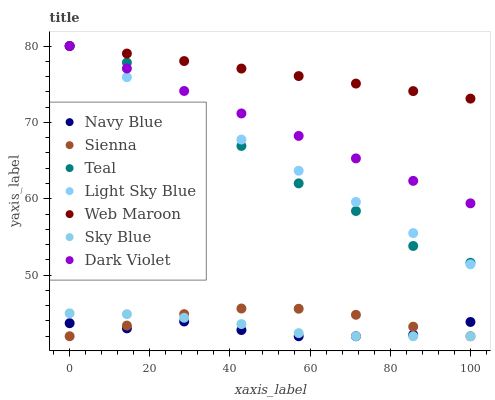Does Navy Blue have the minimum area under the curve?
Answer yes or no. Yes. Does Web Maroon have the maximum area under the curve?
Answer yes or no. Yes. Does Dark Violet have the minimum area under the curve?
Answer yes or no. No. Does Dark Violet have the maximum area under the curve?
Answer yes or no. No. Is Light Sky Blue the smoothest?
Answer yes or no. Yes. Is Teal the roughest?
Answer yes or no. Yes. Is Web Maroon the smoothest?
Answer yes or no. No. Is Web Maroon the roughest?
Answer yes or no. No. Does Navy Blue have the lowest value?
Answer yes or no. Yes. Does Dark Violet have the lowest value?
Answer yes or no. No. Does Teal have the highest value?
Answer yes or no. Yes. Does Sienna have the highest value?
Answer yes or no. No. Is Sienna less than Dark Violet?
Answer yes or no. Yes. Is Teal greater than Sienna?
Answer yes or no. Yes. Does Dark Violet intersect Light Sky Blue?
Answer yes or no. Yes. Is Dark Violet less than Light Sky Blue?
Answer yes or no. No. Is Dark Violet greater than Light Sky Blue?
Answer yes or no. No. Does Sienna intersect Dark Violet?
Answer yes or no. No. 